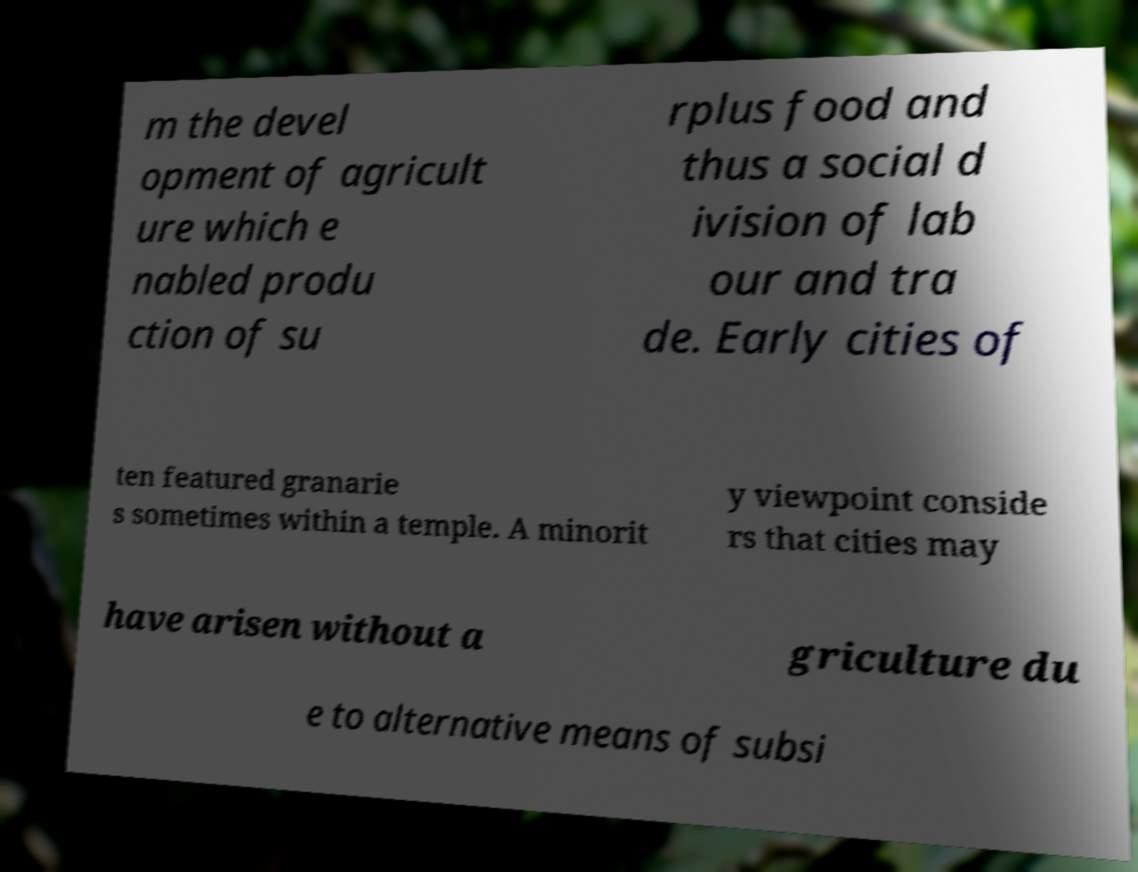I need the written content from this picture converted into text. Can you do that? m the devel opment of agricult ure which e nabled produ ction of su rplus food and thus a social d ivision of lab our and tra de. Early cities of ten featured granarie s sometimes within a temple. A minorit y viewpoint conside rs that cities may have arisen without a griculture du e to alternative means of subsi 